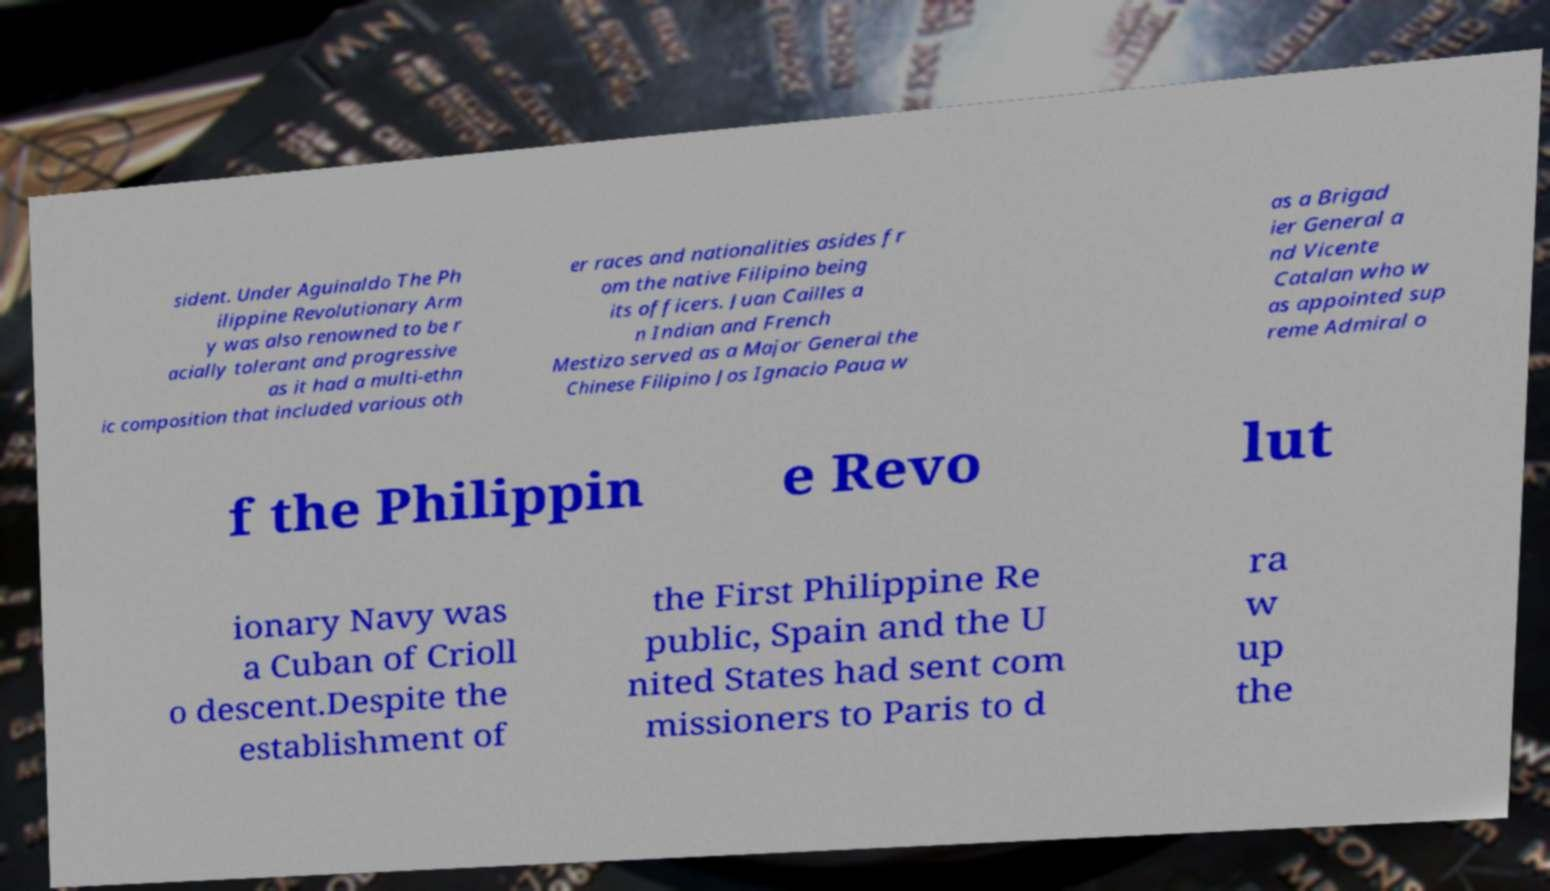Could you assist in decoding the text presented in this image and type it out clearly? sident. Under Aguinaldo The Ph ilippine Revolutionary Arm y was also renowned to be r acially tolerant and progressive as it had a multi-ethn ic composition that included various oth er races and nationalities asides fr om the native Filipino being its officers. Juan Cailles a n Indian and French Mestizo served as a Major General the Chinese Filipino Jos Ignacio Paua w as a Brigad ier General a nd Vicente Catalan who w as appointed sup reme Admiral o f the Philippin e Revo lut ionary Navy was a Cuban of Crioll o descent.Despite the establishment of the First Philippine Re public, Spain and the U nited States had sent com missioners to Paris to d ra w up the 